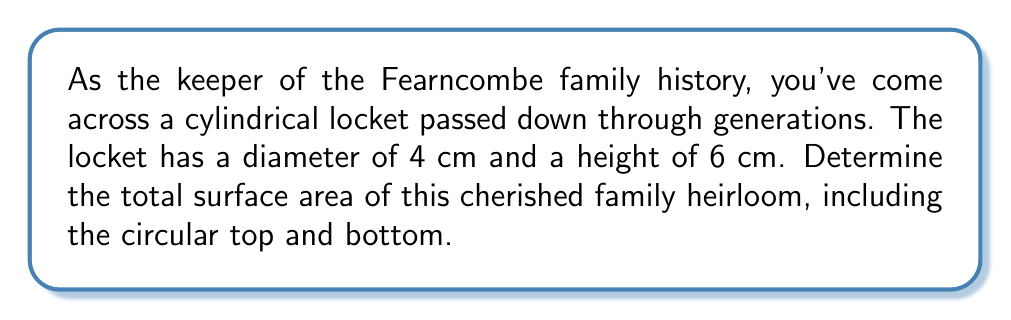What is the answer to this math problem? To find the total surface area of the cylindrical locket, we need to calculate the area of the curved surface (lateral area) and add it to the areas of the two circular ends.

1. Lateral area of the cylinder:
   The formula for the lateral area is $A_l = 2\pi rh$, where $r$ is the radius and $h$ is the height.
   
   Radius $r = \frac{\text{diameter}}{2} = \frac{4}{2} = 2$ cm
   Height $h = 6$ cm
   
   $$A_l = 2\pi(2)(6) = 24\pi \text{ cm}^2$$

2. Area of one circular end:
   The formula for the area of a circle is $A_c = \pi r^2$
   
   $$A_c = \pi(2)^2 = 4\pi \text{ cm}^2$$

3. Total surface area:
   Sum of lateral area and two circular ends
   
   $$A_{\text{total}} = A_l + 2A_c = 24\pi + 2(4\pi) = 32\pi \text{ cm}^2$$

[asy]
import geometry;

size(200);
real r = 2;
real h = 6;

path p = (0,0)--(0,h)--(2r,h)--(2r,0)--cycle;
revolution cyl = revolution(p,Z);

draw(cyl,lightgray);
draw(circle((0,0,0),r));
draw(circle((0,h,0),r));
draw((r,0,0)--(r,h,0),dashed);
draw((0,h/2,0)--(r,h/2,0),Arrow);

label("4 cm",((r,h/2,0)),E);
label("6 cm",(2r,h/2,0),E);

[/asy]
Answer: The total surface area of the cylindrical family heirloom locket is $32\pi \text{ cm}^2$ or approximately $100.53 \text{ cm}^2$. 